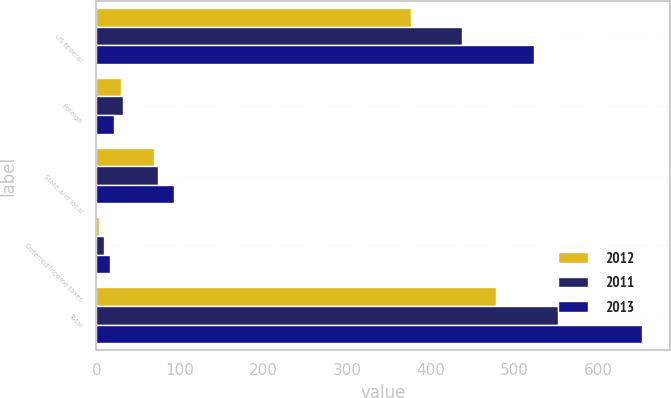Convert chart to OTSL. <chart><loc_0><loc_0><loc_500><loc_500><stacked_bar_chart><ecel><fcel>US federal<fcel>Foreign<fcel>State and local<fcel>Deferred income taxes<fcel>Total<nl><fcel>2012<fcel>375.8<fcel>29.9<fcel>68.8<fcel>2.9<fcel>477.4<nl><fcel>2011<fcel>437.3<fcel>31.3<fcel>73.8<fcel>9.1<fcel>551.5<nl><fcel>2013<fcel>523.3<fcel>20.7<fcel>92.9<fcel>15.8<fcel>652.7<nl></chart> 